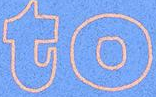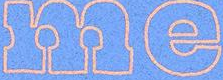What text is displayed in these images sequentially, separated by a semicolon? to; me 